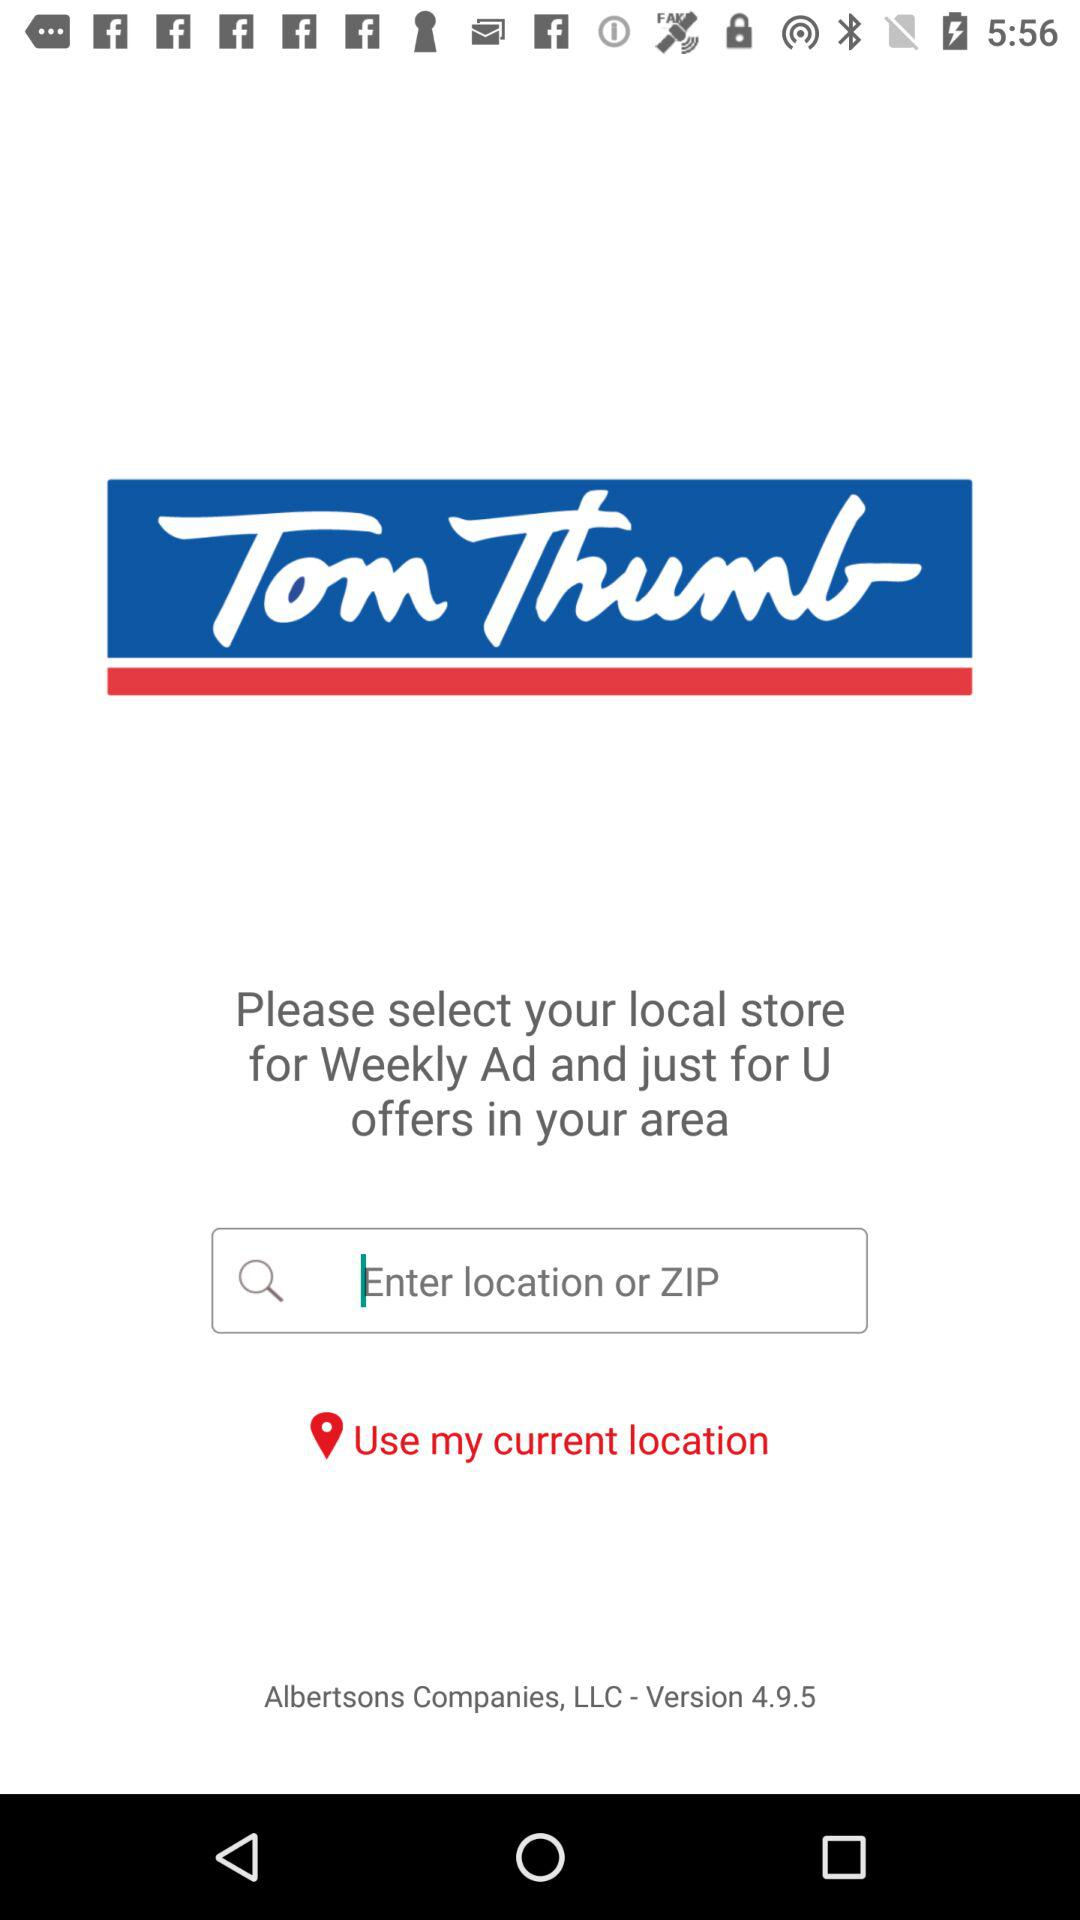What is the name of the application? The name of the application is "Tom Thumb". 